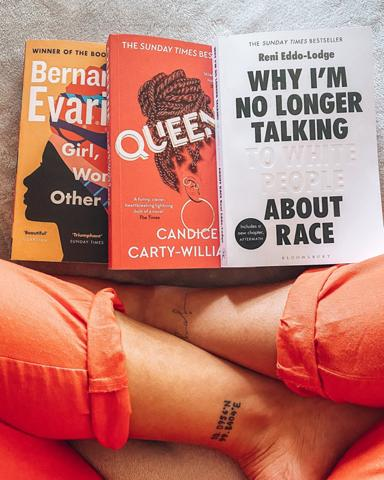What are the two books mentioned in the image? The two prominently displayed books in the image are titled "Why I'm No Longer Talking To White People About Race" by Reni Eddo-Lodge and "Queenie" by Candice Carty-Williams, both of which are captivating works that delve into themes of race and identity in contemporary society. 